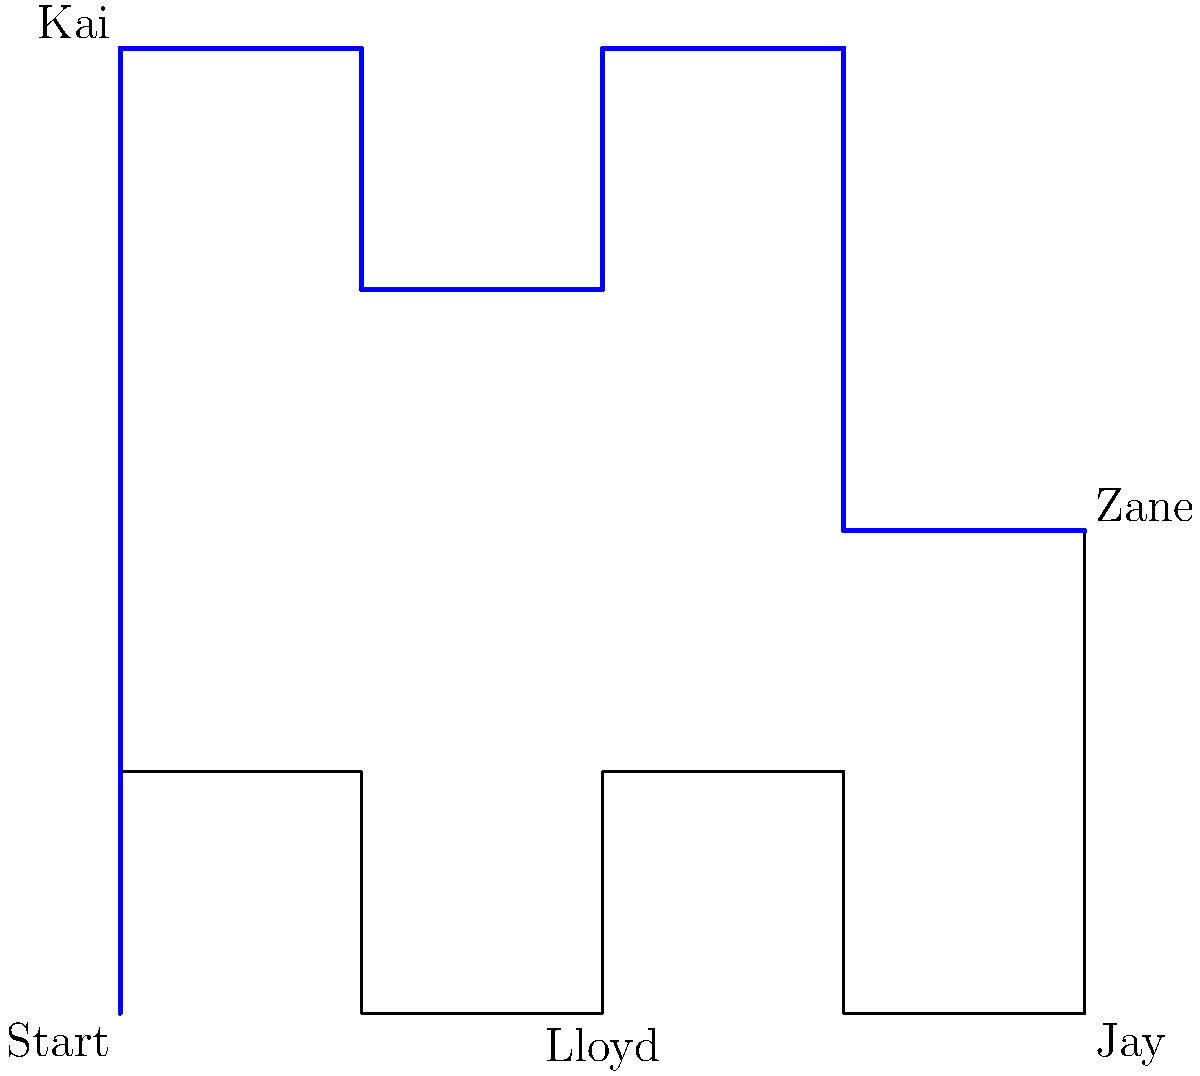In this Ninjago-themed maze, help your child trace the correct path from the "Start" to reach Zane. Which other Ninja do you pass by on the correct path? Let's trace the path step-by-step:

1. Begin at the "Start" point in the bottom-left corner.
2. Move upwards to the top-left corner, where we see Kai.
3. Turn right and move one square.
4. Go down one square.
5. Move right one square.
6. Go up one square.
7. Move right to reach the top-right corner.
8. Go down two squares to reach Zane.

On this path, we only pass by one other Ninja, which is Kai in the top-left corner. We don't pass by Lloyd (bottom-middle) or Jay (bottom-right) on the correct path to reach Zane.
Answer: Kai 